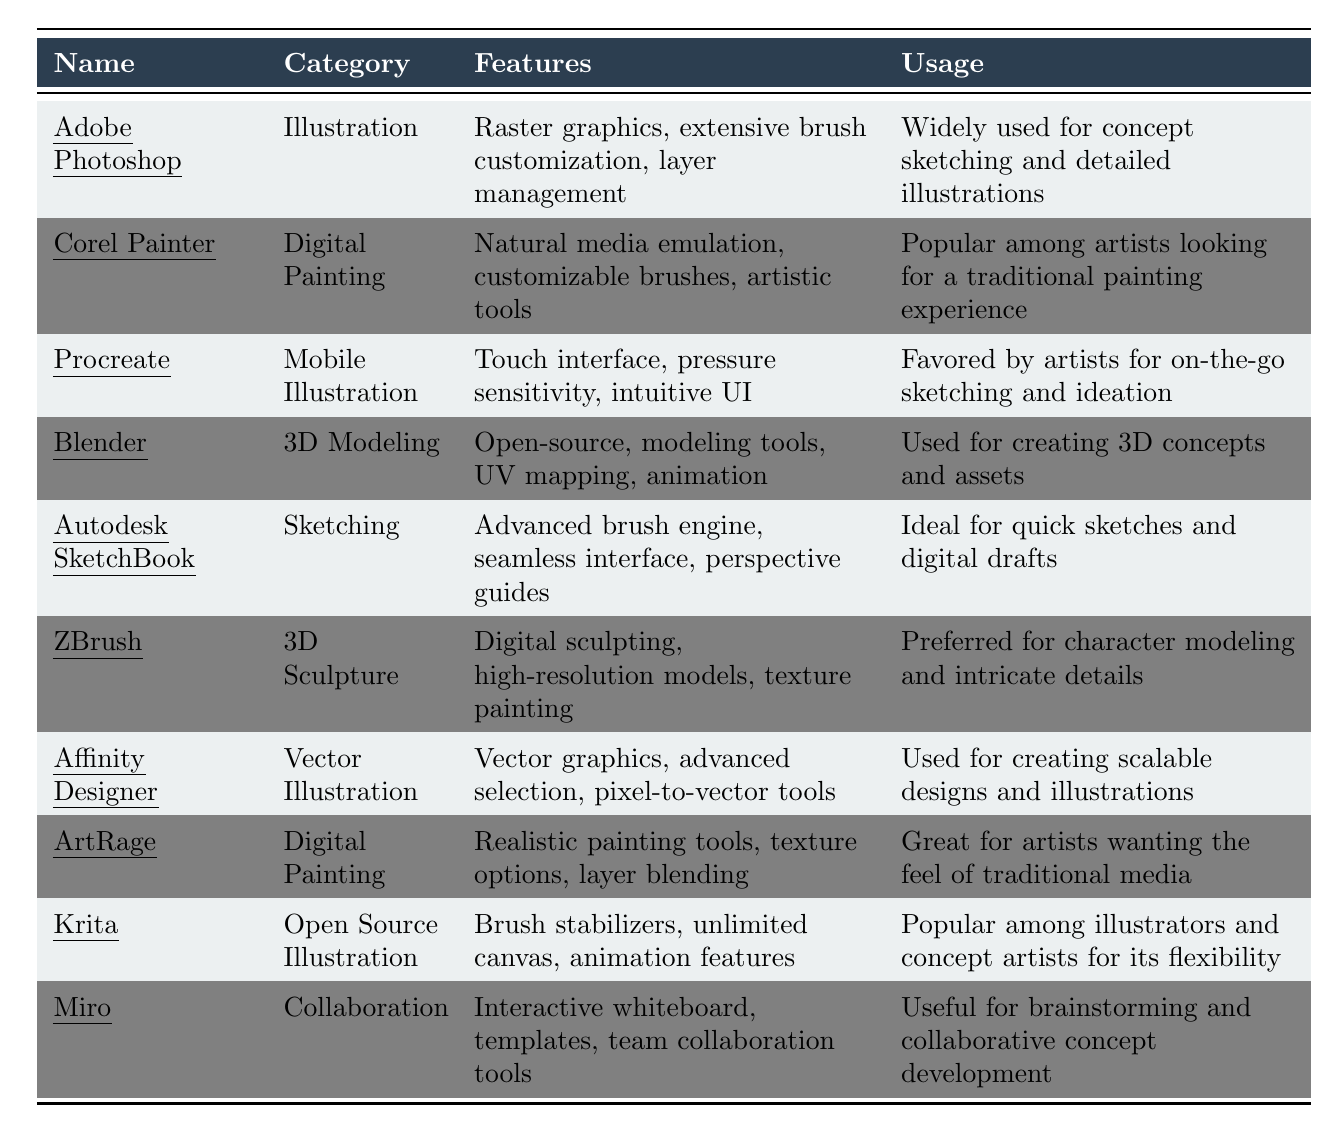What software is categorized under Digital Painting? From the table, there are two entries under the Digital Painting category: Corel Painter and ArtRage.
Answer: Corel Painter and ArtRage Which tool is preferred for character modeling? The table indicates that ZBrush is preferred for character modeling due to its features in digital sculpting and high-resolution models.
Answer: ZBrush What are the features of Krita? According to the table, Krita features brush stabilizers, unlimited canvas, and animation features.
Answer: Brush stabilizers, unlimited canvas, animation features How many tools are listed for 3D modeling? The table shows that there is one tool listed specifically under 3D modeling, which is Blender.
Answer: One Is Procreate favored for on-the-go sketching? The table clearly states that Procreate is favored by artists for on-the-go sketching and ideation.
Answer: Yes Which tool allows for team collaboration? Miro is the tool listed in the table that is categorized under collaboration, providing interactive whiteboard and teamwork features.
Answer: Miro What category does Affinity Designer belong to and how many features does it have? Affinity Designer belongs to the Vector Illustration category. The table lists three features for it: vector graphics, advanced selection, and pixel-to-vector tools.
Answer: Vector Illustration, three features Calculate the total number of software tools listed in the table. The table displays a total of 10 different tools and software for concept artists.
Answer: 10 Which software is ideal for quick sketches? Autodesk SketchBook is identified in the table as ideal for quick sketches and digital drafts.
Answer: Autodesk SketchBook Which tool offers pressure sensitivity? Procreate is the tool that offers pressure sensitivity as part of its features, according to the table.
Answer: Procreate 